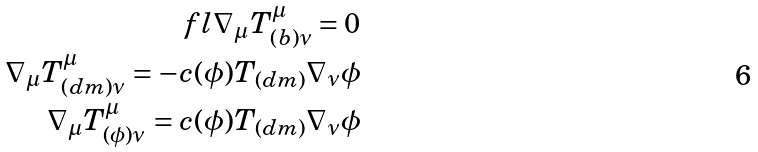Convert formula to latex. <formula><loc_0><loc_0><loc_500><loc_500>\ f l \nabla _ { \mu } T ^ { \mu } _ { ( b ) \nu } = 0 \\ \nabla _ { \mu } T ^ { \mu } _ { ( d m ) \nu } = - c ( \phi ) T _ { ( d m ) } \nabla _ { \nu } \phi \\ \nabla _ { \mu } T ^ { \mu } _ { ( \phi ) \nu } = c ( \phi ) T _ { ( d m ) } \nabla _ { \nu } \phi</formula> 